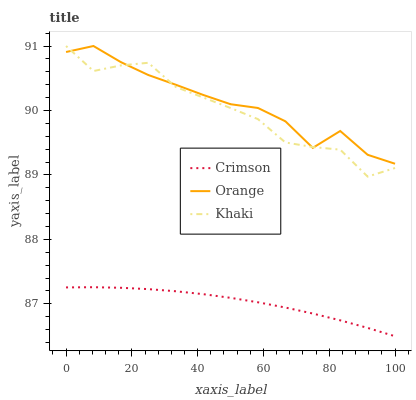Does Khaki have the minimum area under the curve?
Answer yes or no. No. Does Khaki have the maximum area under the curve?
Answer yes or no. No. Is Orange the smoothest?
Answer yes or no. No. Is Orange the roughest?
Answer yes or no. No. Does Khaki have the lowest value?
Answer yes or no. No. Is Crimson less than Orange?
Answer yes or no. Yes. Is Khaki greater than Crimson?
Answer yes or no. Yes. Does Crimson intersect Orange?
Answer yes or no. No. 